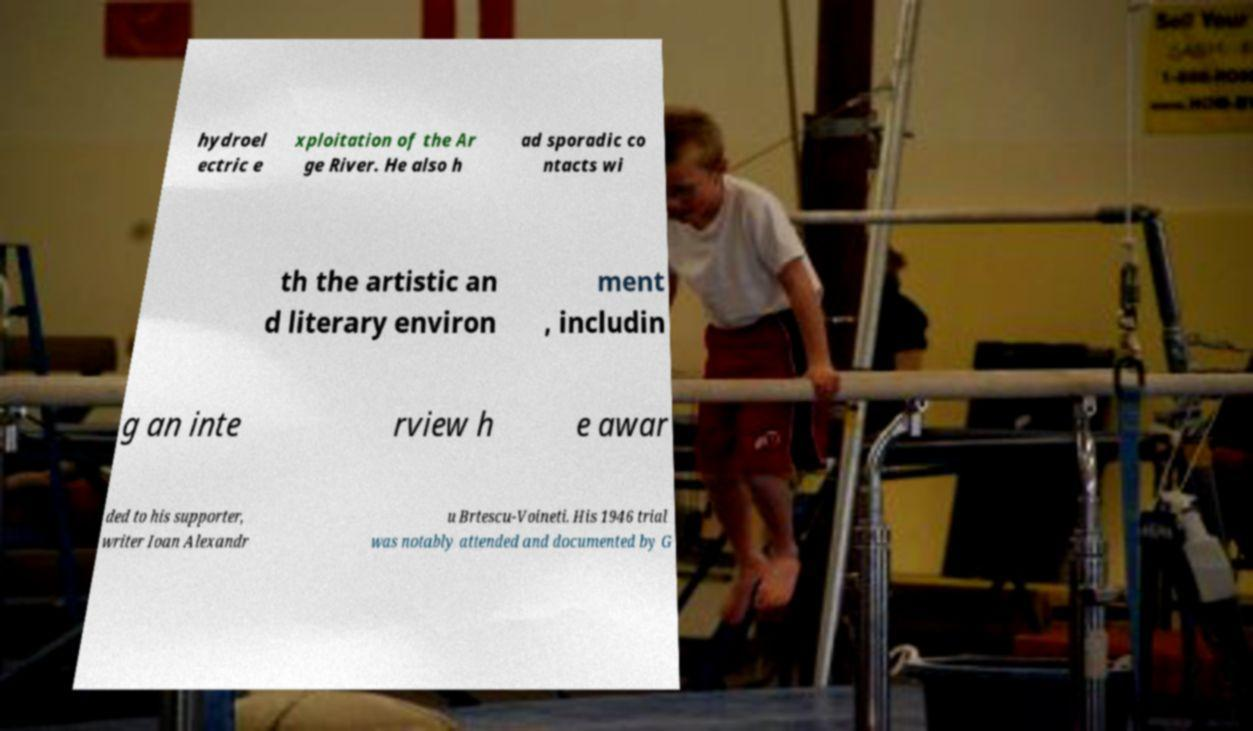I need the written content from this picture converted into text. Can you do that? hydroel ectric e xploitation of the Ar ge River. He also h ad sporadic co ntacts wi th the artistic an d literary environ ment , includin g an inte rview h e awar ded to his supporter, writer Ioan Alexandr u Brtescu-Voineti. His 1946 trial was notably attended and documented by G 